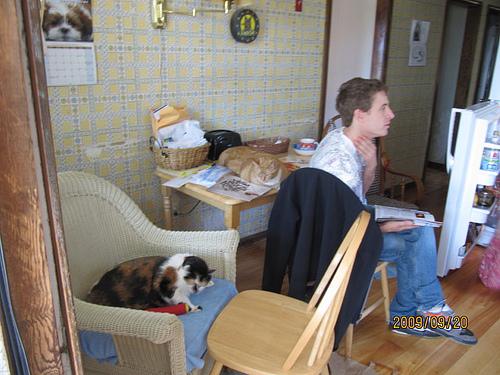How many cats are in the picture?
Write a very short answer. 2. Is the fridge door opened?
Quick response, please. Yes. Is there an animal sleeping on the table?
Concise answer only. Yes. 